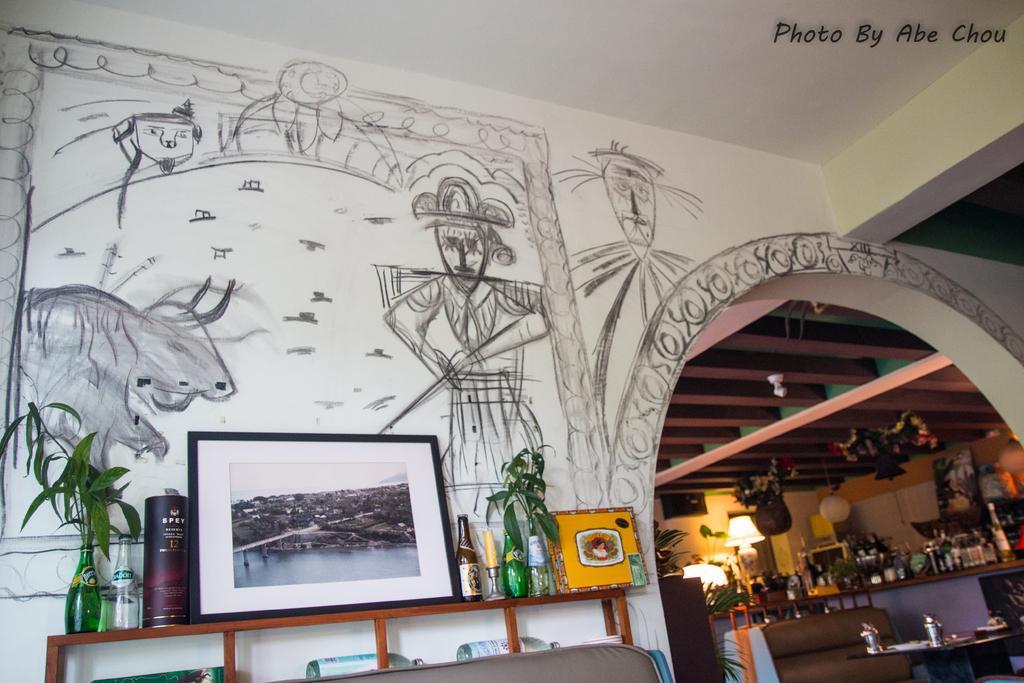Please provide a concise description of this image. in the room there are many things on the wall there was a design near to the wall there was table on the table there was many things. 